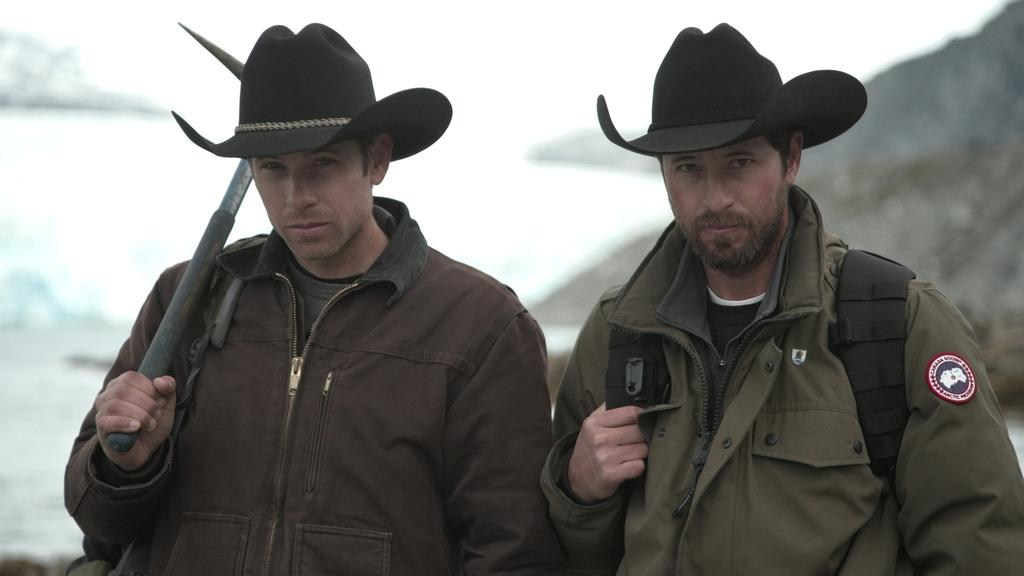How many people are in the image? There are two people in the image. What are the people wearing on their heads? Both people are wearing hats. What is one person holding in the image? One person is holding an ax. What is the other person wearing besides the hat? The other person is wearing a bag. What type of environment is depicted in the image? There is water and rocks visible in the image, suggesting a natural setting. Can you see any zebras grazing on the stem of a plant in the image? There are no zebras or plants with stems present in the image. What type of meat is being prepared by the person holding the ax in the image? There is no meat visible in the image, nor is there any indication that the person holding the ax is preparing meat. 